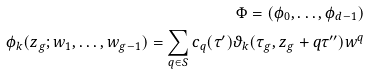<formula> <loc_0><loc_0><loc_500><loc_500>\Phi = ( \phi _ { 0 } , \dots , \phi _ { d - 1 } ) \\ \phi _ { k } ( z _ { g } ; w _ { 1 } , \dots , w _ { g - 1 } ) = \sum _ { q \in S } c _ { q } ( \tau ^ { \prime } ) \vartheta _ { k } ( \tau _ { g } , z _ { g } + q \tau ^ { \prime \prime } ) w ^ { q }</formula> 